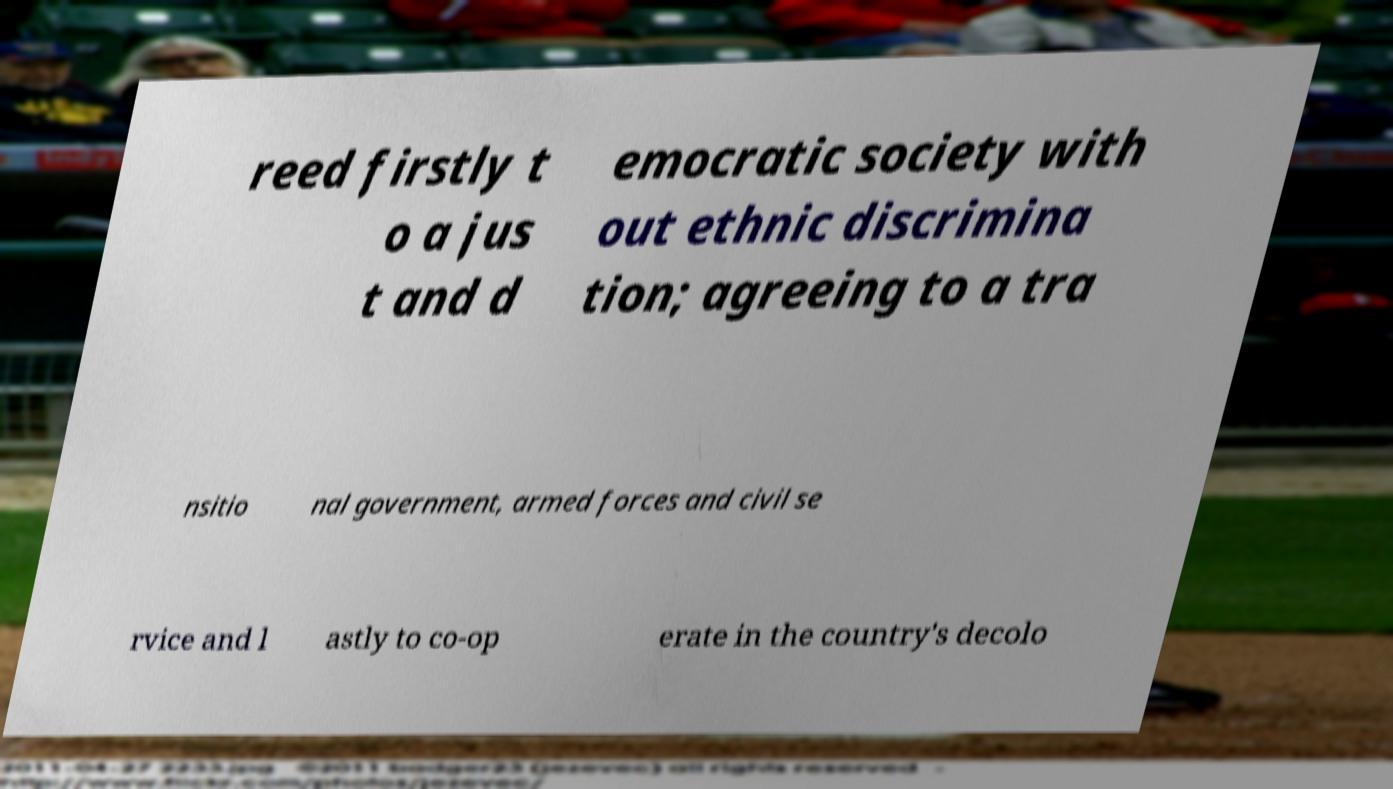There's text embedded in this image that I need extracted. Can you transcribe it verbatim? reed firstly t o a jus t and d emocratic society with out ethnic discrimina tion; agreeing to a tra nsitio nal government, armed forces and civil se rvice and l astly to co-op erate in the country's decolo 